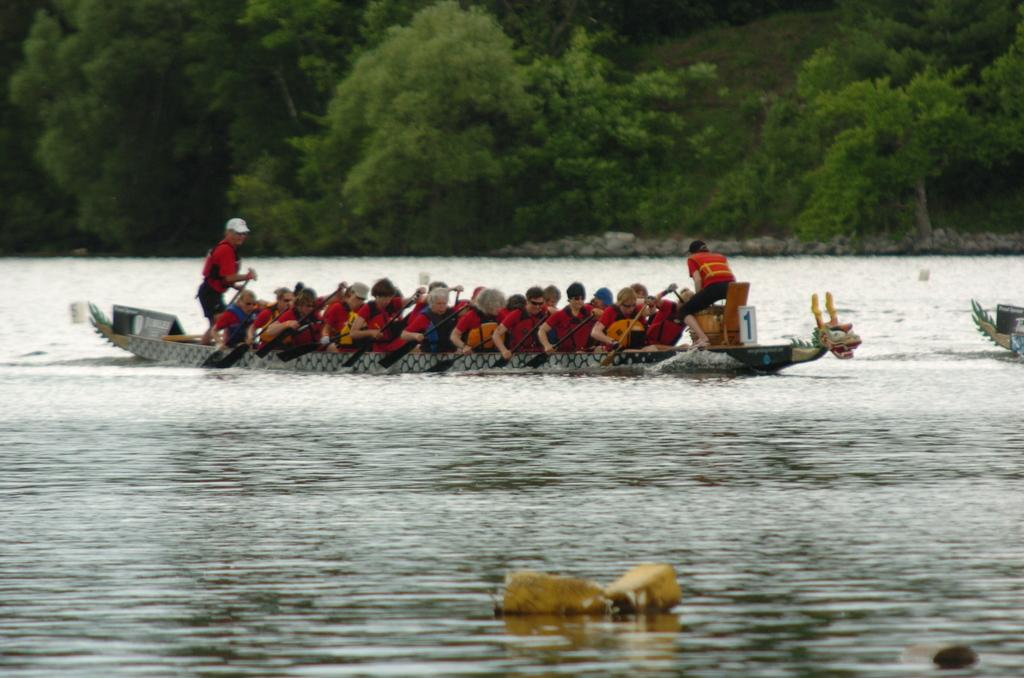What activity are the people in the image engaged in? The people in the image are sailing a boat. What can be seen in the background of the image? There are trees in the background of the image. What is visible at the bottom of the image? There is water visible at the bottom of the image. What type of bread is being baked in the oven in the image? There is no oven or bread present in the image; it features people sailing a boat with trees in the background and water at the bottom. 